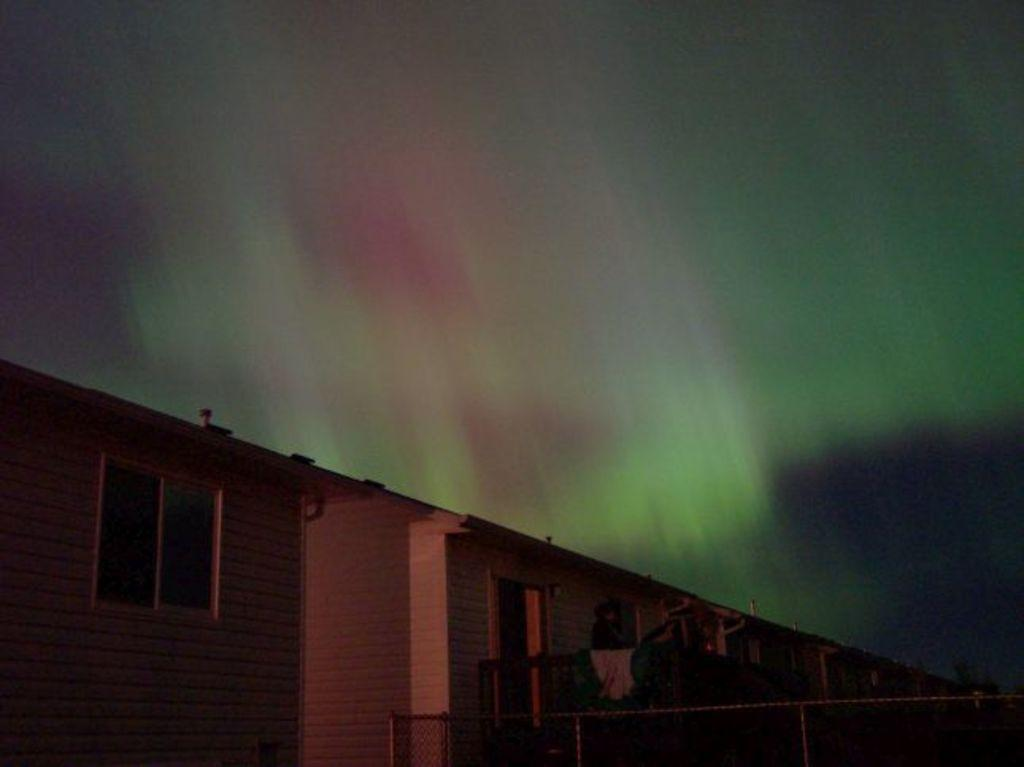What type of structures can be seen in the image? There are buildings in the image. What is the purpose of the barrier in the image? There is a fence in the image, which serves as a barrier or boundary. What part of the natural environment is visible in the image? The sky is visible in the image. What type of eggs can be seen in the image? There are no eggs present in the image. Is there any blood visible in the image? There is no blood visible in the image. 